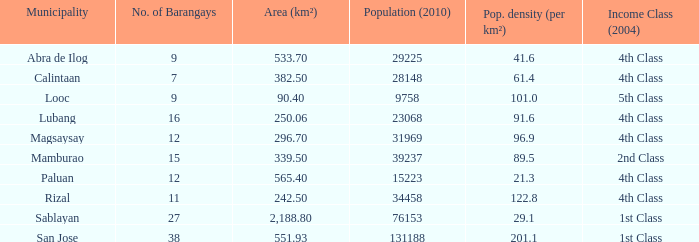List the population density per kilometer for the city of calintaan? 61.4. 